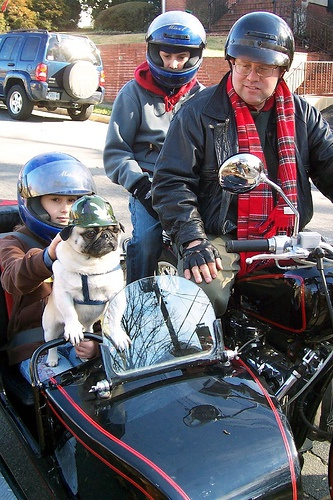Describe the objects in this image and their specific colors. I can see people in tan, black, gray, and darkblue tones, motorcycle in tan, black, gray, white, and darkgray tones, people in tan, black, gray, and white tones, people in tan, black, lightgray, gray, and maroon tones, and dog in tan, white, darkgray, gray, and black tones in this image. 